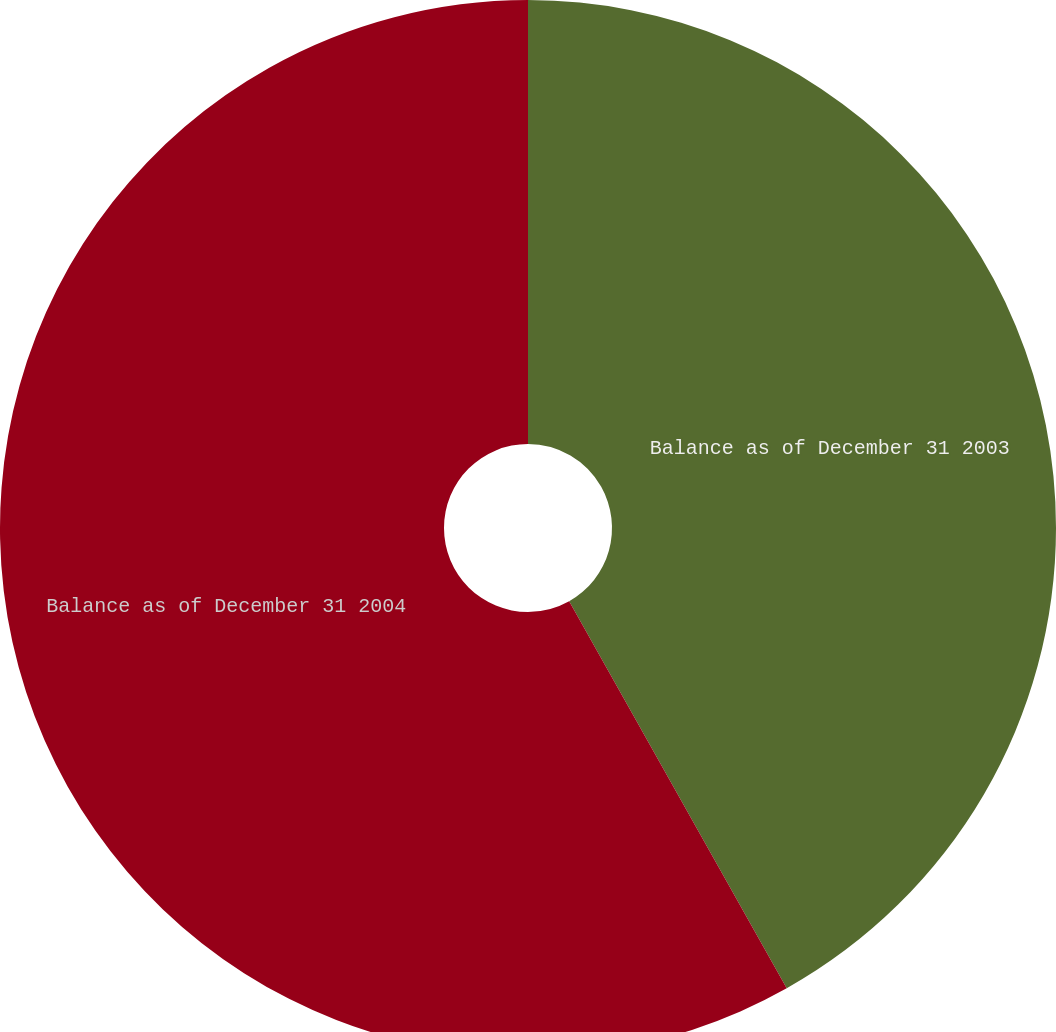Convert chart to OTSL. <chart><loc_0><loc_0><loc_500><loc_500><pie_chart><fcel>Balance as of December 31 2003<fcel>Balance as of December 31 2004<nl><fcel>41.85%<fcel>58.15%<nl></chart> 